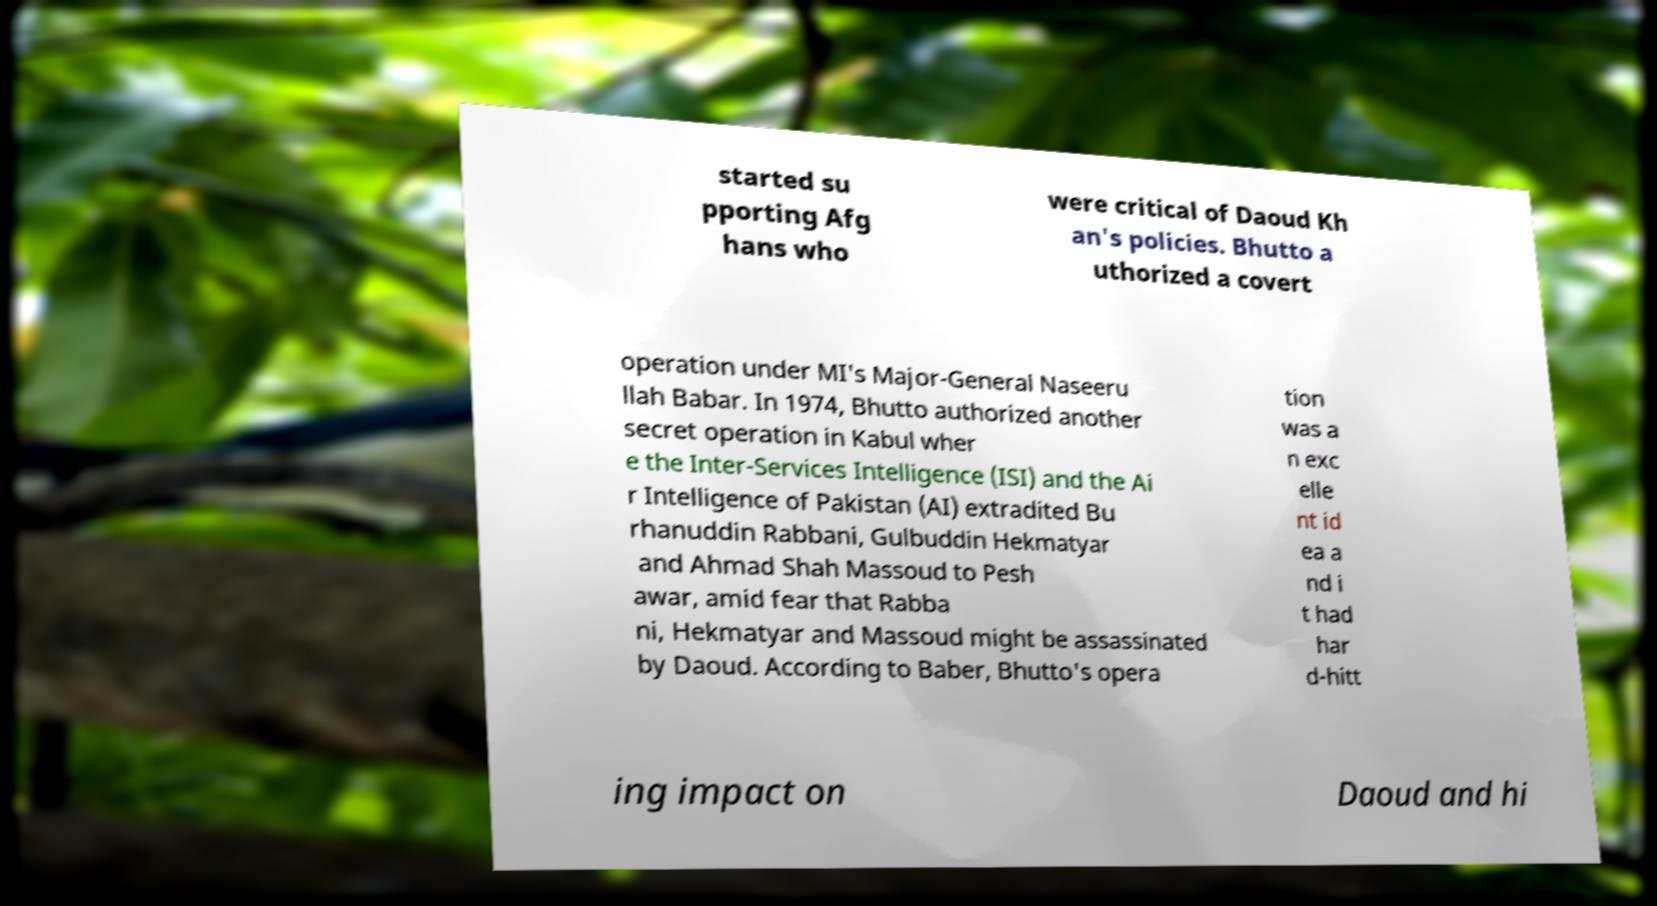Could you assist in decoding the text presented in this image and type it out clearly? started su pporting Afg hans who were critical of Daoud Kh an's policies. Bhutto a uthorized a covert operation under MI's Major-General Naseeru llah Babar. In 1974, Bhutto authorized another secret operation in Kabul wher e the Inter-Services Intelligence (ISI) and the Ai r Intelligence of Pakistan (AI) extradited Bu rhanuddin Rabbani, Gulbuddin Hekmatyar and Ahmad Shah Massoud to Pesh awar, amid fear that Rabba ni, Hekmatyar and Massoud might be assassinated by Daoud. According to Baber, Bhutto's opera tion was a n exc elle nt id ea a nd i t had har d-hitt ing impact on Daoud and hi 